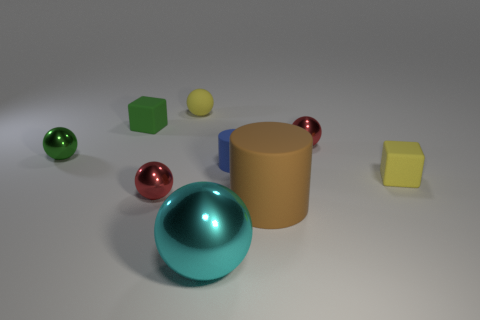What shape is the small matte object that is the same color as the tiny rubber ball?
Your answer should be very brief. Cube. What size is the other matte thing that is the same shape as the tiny blue matte object?
Keep it short and to the point. Large. There is a tiny yellow rubber object that is behind the blue matte cylinder; is it the same shape as the cyan metallic thing?
Provide a short and direct response. Yes. What color is the tiny block that is to the right of the rubber sphere?
Your response must be concise. Yellow. How many other things are there of the same size as the rubber sphere?
Provide a succinct answer. 6. Is there any other thing that has the same shape as the cyan object?
Provide a short and direct response. Yes. Are there the same number of small green shiny objects that are on the right side of the big brown matte cylinder and large purple shiny spheres?
Give a very brief answer. Yes. What number of small blue cylinders are made of the same material as the large sphere?
Provide a succinct answer. 0. There is a big thing that is the same material as the green sphere; what color is it?
Your answer should be very brief. Cyan. Is the shape of the blue rubber object the same as the green metallic thing?
Your answer should be compact. No. 